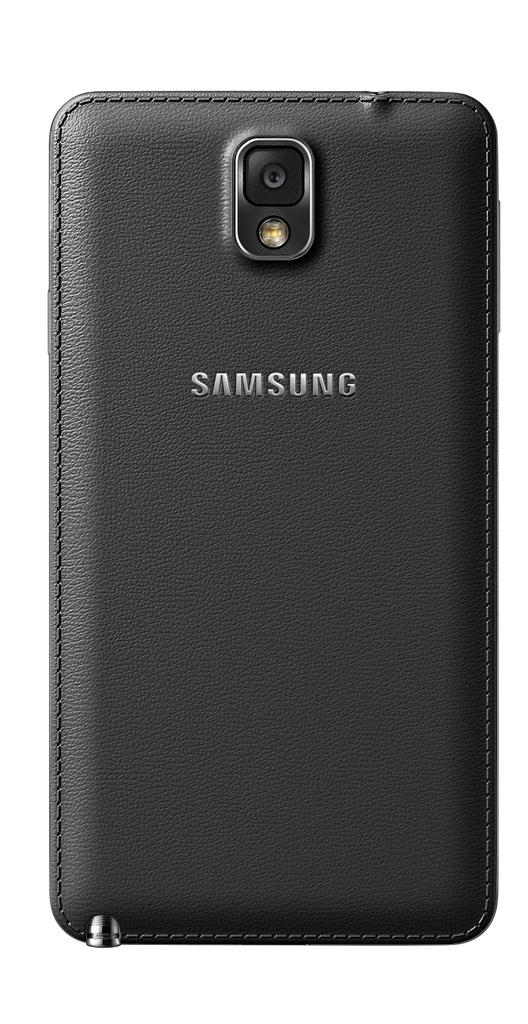What part of the mobile device is visible in the image? The back side of a mobile device is visible in the image. What feature can be seen on the mobile device? There is a camera on the mobile device. What else is present on the mobile device? There is a light on the mobile device. What information can be read on the mobile device? There is some text visible on the mobile device. What is the cause of the surprise in the image? There is no surprise present in the image; it shows the back side of a mobile device with a camera, light, and text. 